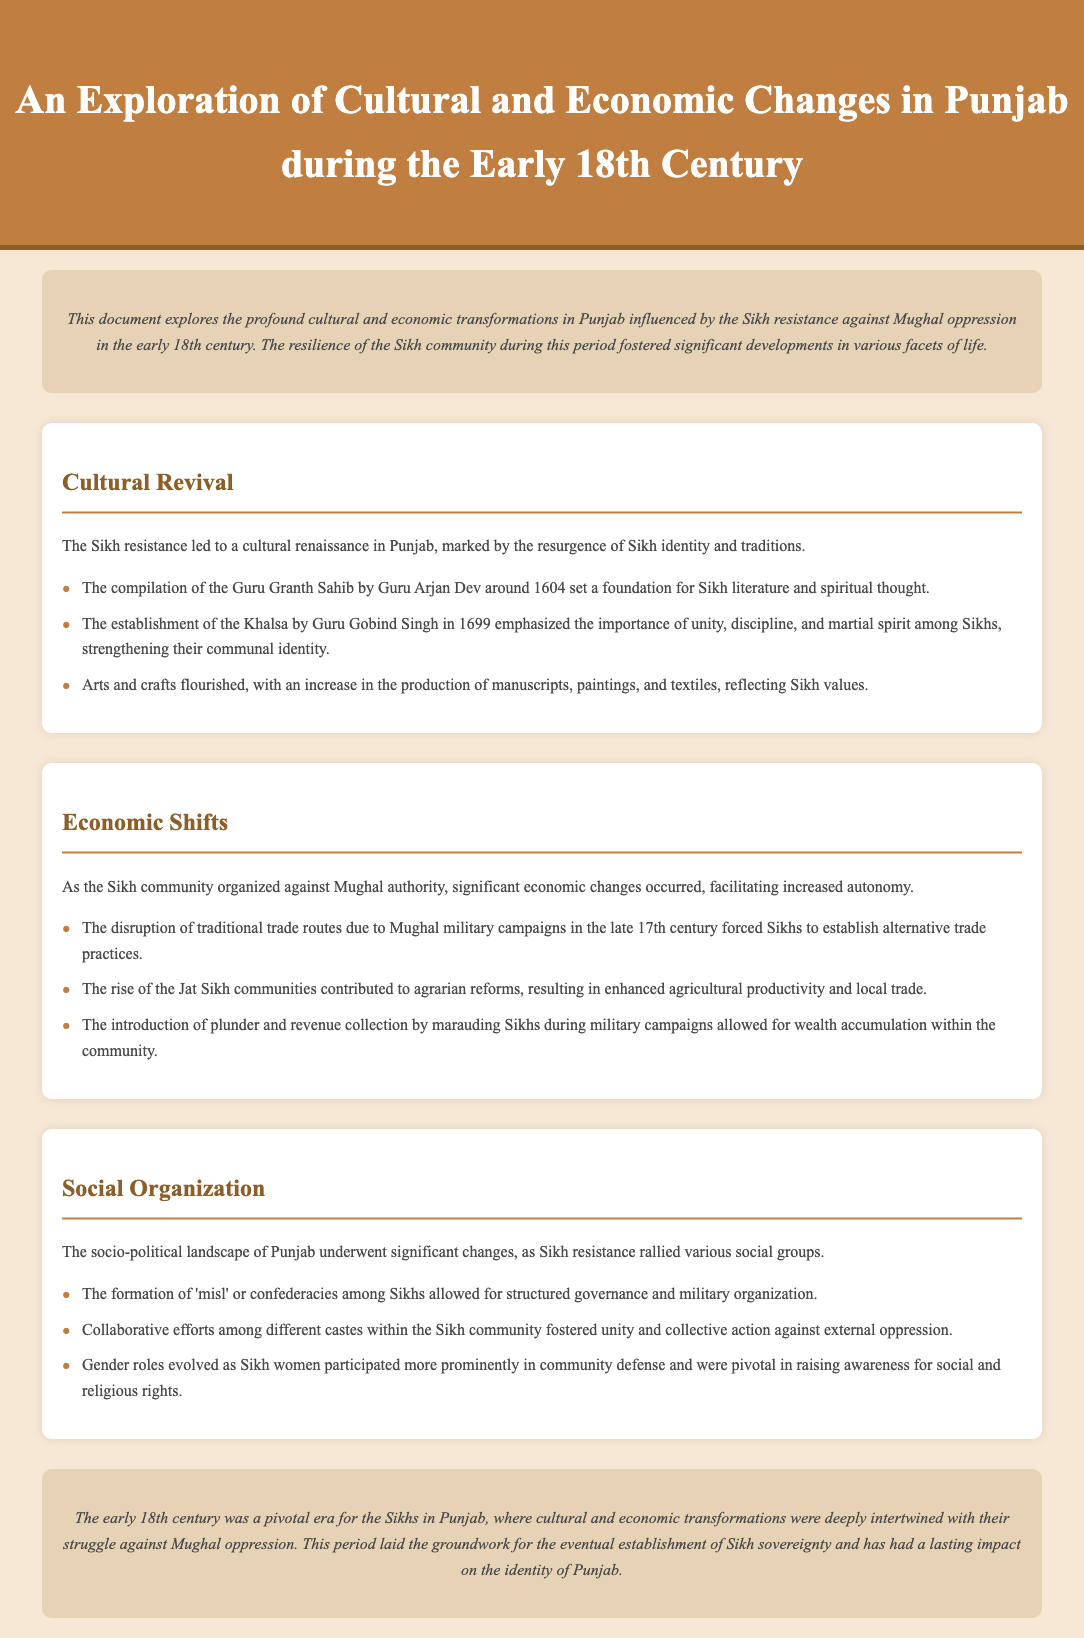What was compiled by Guru Arjan Dev around 1604? The document states that the compilation of the Guru Granth Sahib by Guru Arjan Dev served as a foundation for Sikh literature and spiritual thought.
Answer: Guru Granth Sahib What significant event occurred in 1699? The text mentions that the establishment of the Khalsa by Guru Gobind Singh in 1699 emphasized the importance of Sikh unity and discipline.
Answer: Establishment of the Khalsa What economic change occurred due to Mughal military campaigns? The document describes that the disruption of traditional trade routes by Mughal military campaigns in the late 17th century forced Sikhs to develop alternative trade practices.
Answer: Alternative trade practices What social structure was formed among Sikhs? The document highlights the formation of 'misl' or confederacies among Sikhs, which provided a framework for governance and military organization.
Answer: Misl How did the economic status of Sikh communities change? The text indicates that the rise of the Jat Sikh communities contributed to agrarian reforms that enhanced agricultural productivity and local trade.
Answer: Agricultural productivity What role did Sikh women take during this period? The document states that Sikh women participated more prominently in community defense and raised awareness for social and religious rights.
Answer: Community defense What impact did cultural and economic transformations have on Sikh identity? The document concludes that these transformations were deeply intertwined with Sikh struggles and laid the groundwork for Sikh sovereignty.
Answer: Groundwork for Sikh sovereignty 